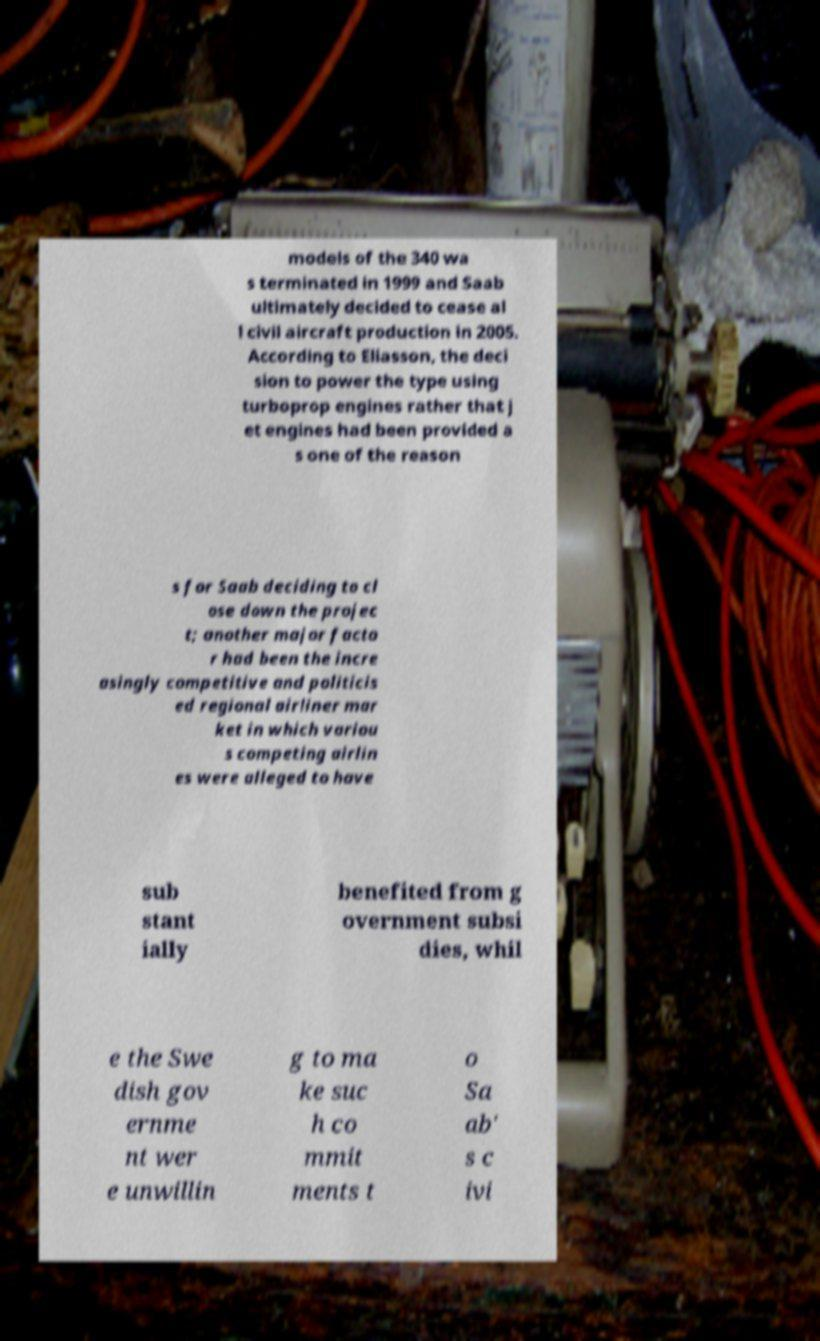There's text embedded in this image that I need extracted. Can you transcribe it verbatim? models of the 340 wa s terminated in 1999 and Saab ultimately decided to cease al l civil aircraft production in 2005. According to Eliasson, the deci sion to power the type using turboprop engines rather that j et engines had been provided a s one of the reason s for Saab deciding to cl ose down the projec t; another major facto r had been the incre asingly competitive and politicis ed regional airliner mar ket in which variou s competing airlin es were alleged to have sub stant ially benefited from g overnment subsi dies, whil e the Swe dish gov ernme nt wer e unwillin g to ma ke suc h co mmit ments t o Sa ab' s c ivi 